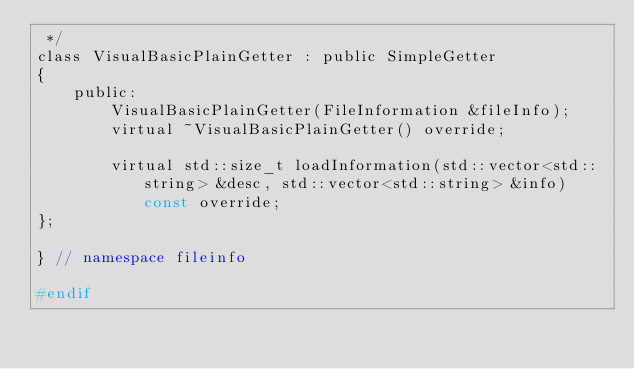<code> <loc_0><loc_0><loc_500><loc_500><_C_> */
class VisualBasicPlainGetter : public SimpleGetter
{
	public:
		VisualBasicPlainGetter(FileInformation &fileInfo);
		virtual ~VisualBasicPlainGetter() override;

		virtual std::size_t loadInformation(std::vector<std::string> &desc, std::vector<std::string> &info) const override;
};

} // namespace fileinfo

#endif
</code> 